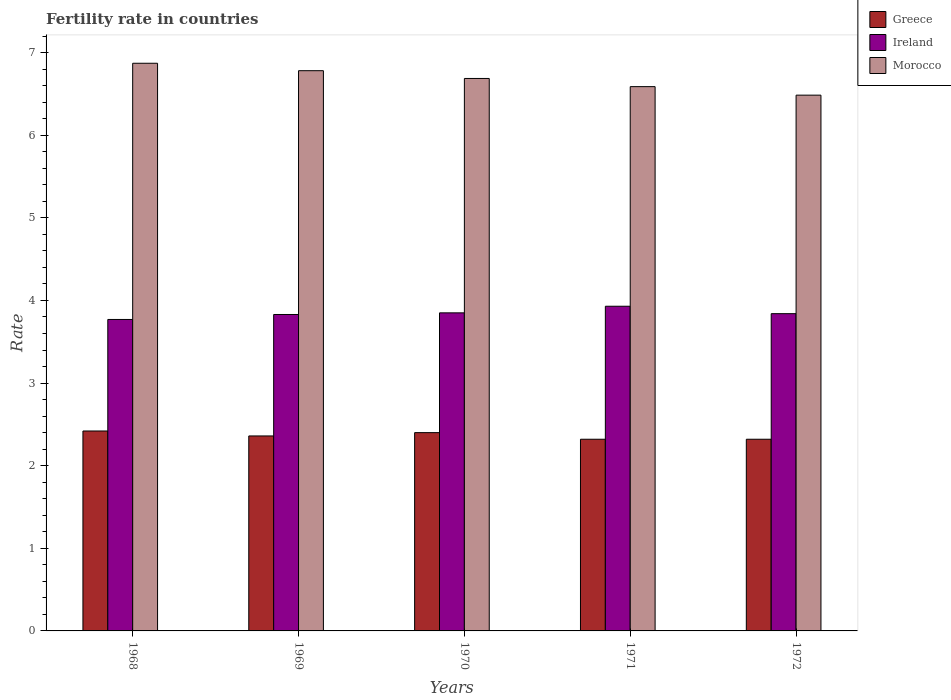How many groups of bars are there?
Give a very brief answer. 5. Are the number of bars on each tick of the X-axis equal?
Your answer should be very brief. Yes. In how many cases, is the number of bars for a given year not equal to the number of legend labels?
Your answer should be very brief. 0. What is the fertility rate in Ireland in 1971?
Offer a terse response. 3.93. Across all years, what is the maximum fertility rate in Ireland?
Provide a short and direct response. 3.93. Across all years, what is the minimum fertility rate in Morocco?
Offer a very short reply. 6.49. In which year was the fertility rate in Ireland maximum?
Give a very brief answer. 1971. In which year was the fertility rate in Ireland minimum?
Your answer should be compact. 1968. What is the total fertility rate in Morocco in the graph?
Give a very brief answer. 33.41. What is the difference between the fertility rate in Ireland in 1969 and that in 1971?
Provide a succinct answer. -0.1. What is the difference between the fertility rate in Ireland in 1970 and the fertility rate in Greece in 1971?
Make the answer very short. 1.53. What is the average fertility rate in Ireland per year?
Make the answer very short. 3.84. In the year 1968, what is the difference between the fertility rate in Morocco and fertility rate in Ireland?
Your answer should be very brief. 3.1. What is the ratio of the fertility rate in Morocco in 1968 to that in 1970?
Give a very brief answer. 1.03. Is the fertility rate in Ireland in 1968 less than that in 1972?
Your response must be concise. Yes. Is the difference between the fertility rate in Morocco in 1969 and 1972 greater than the difference between the fertility rate in Ireland in 1969 and 1972?
Your response must be concise. Yes. What is the difference between the highest and the second highest fertility rate in Ireland?
Make the answer very short. 0.08. What is the difference between the highest and the lowest fertility rate in Morocco?
Your answer should be very brief. 0.39. In how many years, is the fertility rate in Greece greater than the average fertility rate in Greece taken over all years?
Offer a very short reply. 2. What does the 2nd bar from the left in 1968 represents?
Ensure brevity in your answer.  Ireland. How many bars are there?
Offer a terse response. 15. Are all the bars in the graph horizontal?
Ensure brevity in your answer.  No. Are the values on the major ticks of Y-axis written in scientific E-notation?
Provide a short and direct response. No. Does the graph contain grids?
Your response must be concise. No. Where does the legend appear in the graph?
Your answer should be compact. Top right. How many legend labels are there?
Give a very brief answer. 3. How are the legend labels stacked?
Provide a short and direct response. Vertical. What is the title of the graph?
Give a very brief answer. Fertility rate in countries. What is the label or title of the X-axis?
Your response must be concise. Years. What is the label or title of the Y-axis?
Your answer should be compact. Rate. What is the Rate of Greece in 1968?
Offer a terse response. 2.42. What is the Rate in Ireland in 1968?
Offer a terse response. 3.77. What is the Rate in Morocco in 1968?
Ensure brevity in your answer.  6.87. What is the Rate of Greece in 1969?
Your answer should be very brief. 2.36. What is the Rate of Ireland in 1969?
Provide a succinct answer. 3.83. What is the Rate in Morocco in 1969?
Keep it short and to the point. 6.78. What is the Rate of Greece in 1970?
Make the answer very short. 2.4. What is the Rate of Ireland in 1970?
Provide a succinct answer. 3.85. What is the Rate of Morocco in 1970?
Your answer should be compact. 6.69. What is the Rate of Greece in 1971?
Keep it short and to the point. 2.32. What is the Rate in Ireland in 1971?
Provide a succinct answer. 3.93. What is the Rate of Morocco in 1971?
Make the answer very short. 6.59. What is the Rate of Greece in 1972?
Make the answer very short. 2.32. What is the Rate of Ireland in 1972?
Your answer should be compact. 3.84. What is the Rate of Morocco in 1972?
Provide a succinct answer. 6.49. Across all years, what is the maximum Rate of Greece?
Keep it short and to the point. 2.42. Across all years, what is the maximum Rate of Ireland?
Provide a succinct answer. 3.93. Across all years, what is the maximum Rate of Morocco?
Your answer should be compact. 6.87. Across all years, what is the minimum Rate in Greece?
Give a very brief answer. 2.32. Across all years, what is the minimum Rate in Ireland?
Give a very brief answer. 3.77. Across all years, what is the minimum Rate of Morocco?
Your response must be concise. 6.49. What is the total Rate in Greece in the graph?
Provide a short and direct response. 11.82. What is the total Rate in Ireland in the graph?
Keep it short and to the point. 19.22. What is the total Rate in Morocco in the graph?
Offer a very short reply. 33.41. What is the difference between the Rate of Ireland in 1968 and that in 1969?
Offer a very short reply. -0.06. What is the difference between the Rate in Morocco in 1968 and that in 1969?
Keep it short and to the point. 0.09. What is the difference between the Rate of Greece in 1968 and that in 1970?
Provide a short and direct response. 0.02. What is the difference between the Rate of Ireland in 1968 and that in 1970?
Provide a short and direct response. -0.08. What is the difference between the Rate of Morocco in 1968 and that in 1970?
Provide a short and direct response. 0.18. What is the difference between the Rate of Greece in 1968 and that in 1971?
Provide a short and direct response. 0.1. What is the difference between the Rate in Ireland in 1968 and that in 1971?
Keep it short and to the point. -0.16. What is the difference between the Rate of Morocco in 1968 and that in 1971?
Give a very brief answer. 0.28. What is the difference between the Rate in Greece in 1968 and that in 1972?
Provide a succinct answer. 0.1. What is the difference between the Rate in Ireland in 1968 and that in 1972?
Your answer should be compact. -0.07. What is the difference between the Rate in Morocco in 1968 and that in 1972?
Your response must be concise. 0.39. What is the difference between the Rate of Greece in 1969 and that in 1970?
Your answer should be compact. -0.04. What is the difference between the Rate of Ireland in 1969 and that in 1970?
Ensure brevity in your answer.  -0.02. What is the difference between the Rate of Morocco in 1969 and that in 1970?
Provide a short and direct response. 0.09. What is the difference between the Rate in Morocco in 1969 and that in 1971?
Keep it short and to the point. 0.19. What is the difference between the Rate in Greece in 1969 and that in 1972?
Give a very brief answer. 0.04. What is the difference between the Rate in Ireland in 1969 and that in 1972?
Provide a succinct answer. -0.01. What is the difference between the Rate of Morocco in 1969 and that in 1972?
Provide a short and direct response. 0.3. What is the difference between the Rate in Ireland in 1970 and that in 1971?
Your answer should be very brief. -0.08. What is the difference between the Rate in Morocco in 1970 and that in 1971?
Provide a succinct answer. 0.1. What is the difference between the Rate of Greece in 1970 and that in 1972?
Your response must be concise. 0.08. What is the difference between the Rate of Ireland in 1970 and that in 1972?
Offer a very short reply. 0.01. What is the difference between the Rate of Morocco in 1970 and that in 1972?
Offer a terse response. 0.2. What is the difference between the Rate of Greece in 1971 and that in 1972?
Provide a succinct answer. 0. What is the difference between the Rate of Ireland in 1971 and that in 1972?
Your answer should be very brief. 0.09. What is the difference between the Rate in Morocco in 1971 and that in 1972?
Offer a very short reply. 0.1. What is the difference between the Rate in Greece in 1968 and the Rate in Ireland in 1969?
Your answer should be compact. -1.41. What is the difference between the Rate of Greece in 1968 and the Rate of Morocco in 1969?
Provide a short and direct response. -4.36. What is the difference between the Rate in Ireland in 1968 and the Rate in Morocco in 1969?
Your answer should be very brief. -3.01. What is the difference between the Rate in Greece in 1968 and the Rate in Ireland in 1970?
Keep it short and to the point. -1.43. What is the difference between the Rate in Greece in 1968 and the Rate in Morocco in 1970?
Give a very brief answer. -4.27. What is the difference between the Rate in Ireland in 1968 and the Rate in Morocco in 1970?
Keep it short and to the point. -2.92. What is the difference between the Rate in Greece in 1968 and the Rate in Ireland in 1971?
Your response must be concise. -1.51. What is the difference between the Rate in Greece in 1968 and the Rate in Morocco in 1971?
Your answer should be very brief. -4.17. What is the difference between the Rate of Ireland in 1968 and the Rate of Morocco in 1971?
Your response must be concise. -2.82. What is the difference between the Rate of Greece in 1968 and the Rate of Ireland in 1972?
Keep it short and to the point. -1.42. What is the difference between the Rate of Greece in 1968 and the Rate of Morocco in 1972?
Offer a very short reply. -4.07. What is the difference between the Rate of Ireland in 1968 and the Rate of Morocco in 1972?
Keep it short and to the point. -2.71. What is the difference between the Rate in Greece in 1969 and the Rate in Ireland in 1970?
Offer a terse response. -1.49. What is the difference between the Rate in Greece in 1969 and the Rate in Morocco in 1970?
Your response must be concise. -4.33. What is the difference between the Rate in Ireland in 1969 and the Rate in Morocco in 1970?
Make the answer very short. -2.86. What is the difference between the Rate of Greece in 1969 and the Rate of Ireland in 1971?
Your answer should be compact. -1.57. What is the difference between the Rate in Greece in 1969 and the Rate in Morocco in 1971?
Provide a succinct answer. -4.23. What is the difference between the Rate in Ireland in 1969 and the Rate in Morocco in 1971?
Your response must be concise. -2.76. What is the difference between the Rate of Greece in 1969 and the Rate of Ireland in 1972?
Provide a succinct answer. -1.48. What is the difference between the Rate of Greece in 1969 and the Rate of Morocco in 1972?
Your answer should be very brief. -4.12. What is the difference between the Rate of Ireland in 1969 and the Rate of Morocco in 1972?
Give a very brief answer. -2.65. What is the difference between the Rate in Greece in 1970 and the Rate in Ireland in 1971?
Your answer should be very brief. -1.53. What is the difference between the Rate of Greece in 1970 and the Rate of Morocco in 1971?
Ensure brevity in your answer.  -4.19. What is the difference between the Rate in Ireland in 1970 and the Rate in Morocco in 1971?
Give a very brief answer. -2.74. What is the difference between the Rate of Greece in 1970 and the Rate of Ireland in 1972?
Offer a very short reply. -1.44. What is the difference between the Rate of Greece in 1970 and the Rate of Morocco in 1972?
Your response must be concise. -4.08. What is the difference between the Rate of Ireland in 1970 and the Rate of Morocco in 1972?
Your response must be concise. -2.63. What is the difference between the Rate of Greece in 1971 and the Rate of Ireland in 1972?
Your answer should be compact. -1.52. What is the difference between the Rate of Greece in 1971 and the Rate of Morocco in 1972?
Your response must be concise. -4.17. What is the difference between the Rate of Ireland in 1971 and the Rate of Morocco in 1972?
Offer a very short reply. -2.56. What is the average Rate in Greece per year?
Ensure brevity in your answer.  2.36. What is the average Rate of Ireland per year?
Your answer should be compact. 3.84. What is the average Rate in Morocco per year?
Offer a terse response. 6.68. In the year 1968, what is the difference between the Rate of Greece and Rate of Ireland?
Your answer should be very brief. -1.35. In the year 1968, what is the difference between the Rate in Greece and Rate in Morocco?
Your response must be concise. -4.45. In the year 1968, what is the difference between the Rate in Ireland and Rate in Morocco?
Provide a succinct answer. -3.1. In the year 1969, what is the difference between the Rate in Greece and Rate in Ireland?
Make the answer very short. -1.47. In the year 1969, what is the difference between the Rate of Greece and Rate of Morocco?
Keep it short and to the point. -4.42. In the year 1969, what is the difference between the Rate of Ireland and Rate of Morocco?
Make the answer very short. -2.95. In the year 1970, what is the difference between the Rate in Greece and Rate in Ireland?
Your response must be concise. -1.45. In the year 1970, what is the difference between the Rate in Greece and Rate in Morocco?
Make the answer very short. -4.29. In the year 1970, what is the difference between the Rate of Ireland and Rate of Morocco?
Give a very brief answer. -2.84. In the year 1971, what is the difference between the Rate in Greece and Rate in Ireland?
Make the answer very short. -1.61. In the year 1971, what is the difference between the Rate of Greece and Rate of Morocco?
Provide a short and direct response. -4.27. In the year 1971, what is the difference between the Rate of Ireland and Rate of Morocco?
Your response must be concise. -2.66. In the year 1972, what is the difference between the Rate in Greece and Rate in Ireland?
Offer a terse response. -1.52. In the year 1972, what is the difference between the Rate in Greece and Rate in Morocco?
Provide a short and direct response. -4.17. In the year 1972, what is the difference between the Rate in Ireland and Rate in Morocco?
Your response must be concise. -2.65. What is the ratio of the Rate of Greece in 1968 to that in 1969?
Give a very brief answer. 1.03. What is the ratio of the Rate in Ireland in 1968 to that in 1969?
Provide a succinct answer. 0.98. What is the ratio of the Rate in Morocco in 1968 to that in 1969?
Your response must be concise. 1.01. What is the ratio of the Rate in Greece in 1968 to that in 1970?
Offer a very short reply. 1.01. What is the ratio of the Rate of Ireland in 1968 to that in 1970?
Provide a short and direct response. 0.98. What is the ratio of the Rate of Morocco in 1968 to that in 1970?
Your response must be concise. 1.03. What is the ratio of the Rate of Greece in 1968 to that in 1971?
Provide a succinct answer. 1.04. What is the ratio of the Rate in Ireland in 1968 to that in 1971?
Offer a terse response. 0.96. What is the ratio of the Rate in Morocco in 1968 to that in 1971?
Offer a terse response. 1.04. What is the ratio of the Rate of Greece in 1968 to that in 1972?
Your answer should be compact. 1.04. What is the ratio of the Rate of Ireland in 1968 to that in 1972?
Provide a succinct answer. 0.98. What is the ratio of the Rate in Morocco in 1968 to that in 1972?
Ensure brevity in your answer.  1.06. What is the ratio of the Rate of Greece in 1969 to that in 1970?
Your answer should be very brief. 0.98. What is the ratio of the Rate of Morocco in 1969 to that in 1970?
Offer a very short reply. 1.01. What is the ratio of the Rate of Greece in 1969 to that in 1971?
Provide a succinct answer. 1.02. What is the ratio of the Rate in Ireland in 1969 to that in 1971?
Provide a short and direct response. 0.97. What is the ratio of the Rate of Morocco in 1969 to that in 1971?
Make the answer very short. 1.03. What is the ratio of the Rate in Greece in 1969 to that in 1972?
Your answer should be compact. 1.02. What is the ratio of the Rate in Morocco in 1969 to that in 1972?
Offer a very short reply. 1.05. What is the ratio of the Rate in Greece in 1970 to that in 1971?
Give a very brief answer. 1.03. What is the ratio of the Rate in Ireland in 1970 to that in 1971?
Provide a succinct answer. 0.98. What is the ratio of the Rate in Morocco in 1970 to that in 1971?
Ensure brevity in your answer.  1.01. What is the ratio of the Rate in Greece in 1970 to that in 1972?
Provide a succinct answer. 1.03. What is the ratio of the Rate in Morocco in 1970 to that in 1972?
Offer a terse response. 1.03. What is the ratio of the Rate of Greece in 1971 to that in 1972?
Give a very brief answer. 1. What is the ratio of the Rate of Ireland in 1971 to that in 1972?
Your answer should be compact. 1.02. What is the ratio of the Rate of Morocco in 1971 to that in 1972?
Your response must be concise. 1.02. What is the difference between the highest and the second highest Rate of Morocco?
Make the answer very short. 0.09. What is the difference between the highest and the lowest Rate in Ireland?
Offer a very short reply. 0.16. What is the difference between the highest and the lowest Rate in Morocco?
Keep it short and to the point. 0.39. 